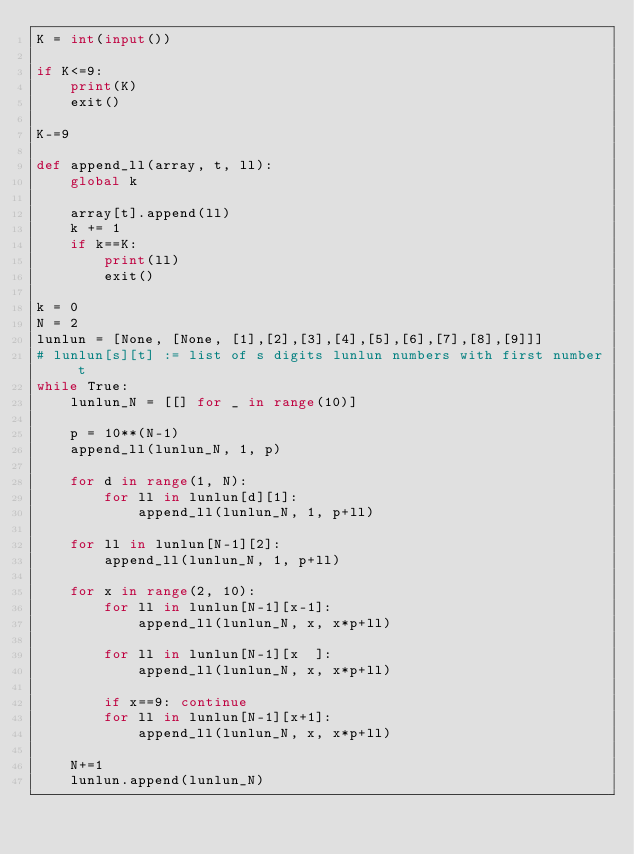<code> <loc_0><loc_0><loc_500><loc_500><_Python_>K = int(input())

if K<=9:
    print(K)
    exit()

K-=9

def append_ll(array, t, ll):
    global k
    
    array[t].append(ll)
    k += 1
    if k==K:
        print(ll)
        exit()

k = 0
N = 2
lunlun = [None, [None, [1],[2],[3],[4],[5],[6],[7],[8],[9]]]
# lunlun[s][t] := list of s digits lunlun numbers with first number t
while True:
    lunlun_N = [[] for _ in range(10)]

    p = 10**(N-1)
    append_ll(lunlun_N, 1, p)
    
    for d in range(1, N):
        for ll in lunlun[d][1]:
            append_ll(lunlun_N, 1, p+ll)

    for ll in lunlun[N-1][2]:
        append_ll(lunlun_N, 1, p+ll)
    
    for x in range(2, 10):
        for ll in lunlun[N-1][x-1]:
            append_ll(lunlun_N, x, x*p+ll)
            
        for ll in lunlun[N-1][x  ]:
            append_ll(lunlun_N, x, x*p+ll)

        if x==9: continue
        for ll in lunlun[N-1][x+1]:
            append_ll(lunlun_N, x, x*p+ll)

    N+=1
    lunlun.append(lunlun_N)
</code> 